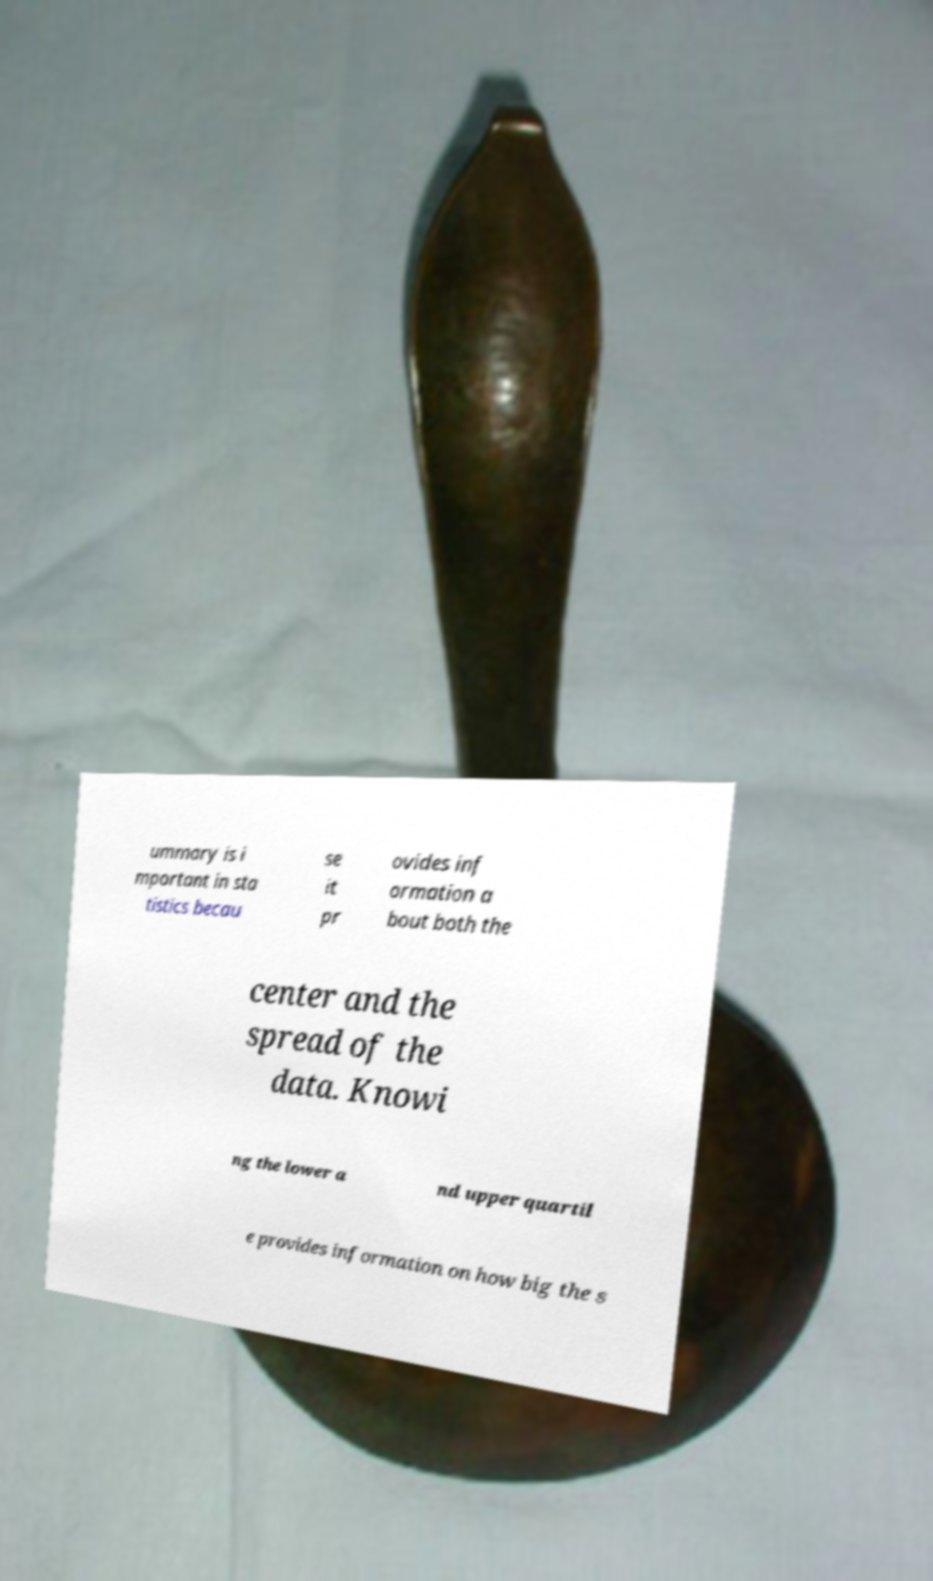There's text embedded in this image that I need extracted. Can you transcribe it verbatim? ummary is i mportant in sta tistics becau se it pr ovides inf ormation a bout both the center and the spread of the data. Knowi ng the lower a nd upper quartil e provides information on how big the s 